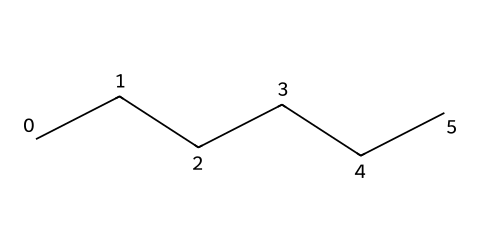What is the name of this chemical? The SMILES representation "CCCCCC" indicates a straight-chain hydrocarbon with six carbon atoms, which is known as hexane.
Answer: hexane How many carbon atoms are in this chemical? The SMILES notation shows "CCCCCC", where each "C" represents a carbon atom, totaling six carbon atoms in the chain.
Answer: six How many hydrogen atoms are in hexane? The formula for alkanes is CnH(2n+2). For hexane (C6), substituting n with 6 results in H(2*6+2) = H14, meaning there are 14 hydrogen atoms.
Answer: fourteen Is hexane a polar or nonpolar solvent? Given its hydrocarbon structure, which lacks significant electronegative atoms, hexane is classified as a nonpolar solvent.
Answer: nonpolar What type of chemical reaction can hexane undergo? Hexane can undergo combustion reactions due to its hydrocarbon nature, wherein it reacts with oxygen to produce carbon dioxide and water.
Answer: combustion What is the primary use of hexane in an office renovation context? Hexane is commonly used as a solvent in adhesives and sealants, particularly in construction or renovation projects, to aid in dissolution and application.
Answer: solvent in adhesives Can hexane dissolve water? Due to its nonpolar nature, hexane does not mix well with polar solvents like water, leading to a lack of solubility.
Answer: no 